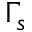<formula> <loc_0><loc_0><loc_500><loc_500>\Gamma _ { s }</formula> 